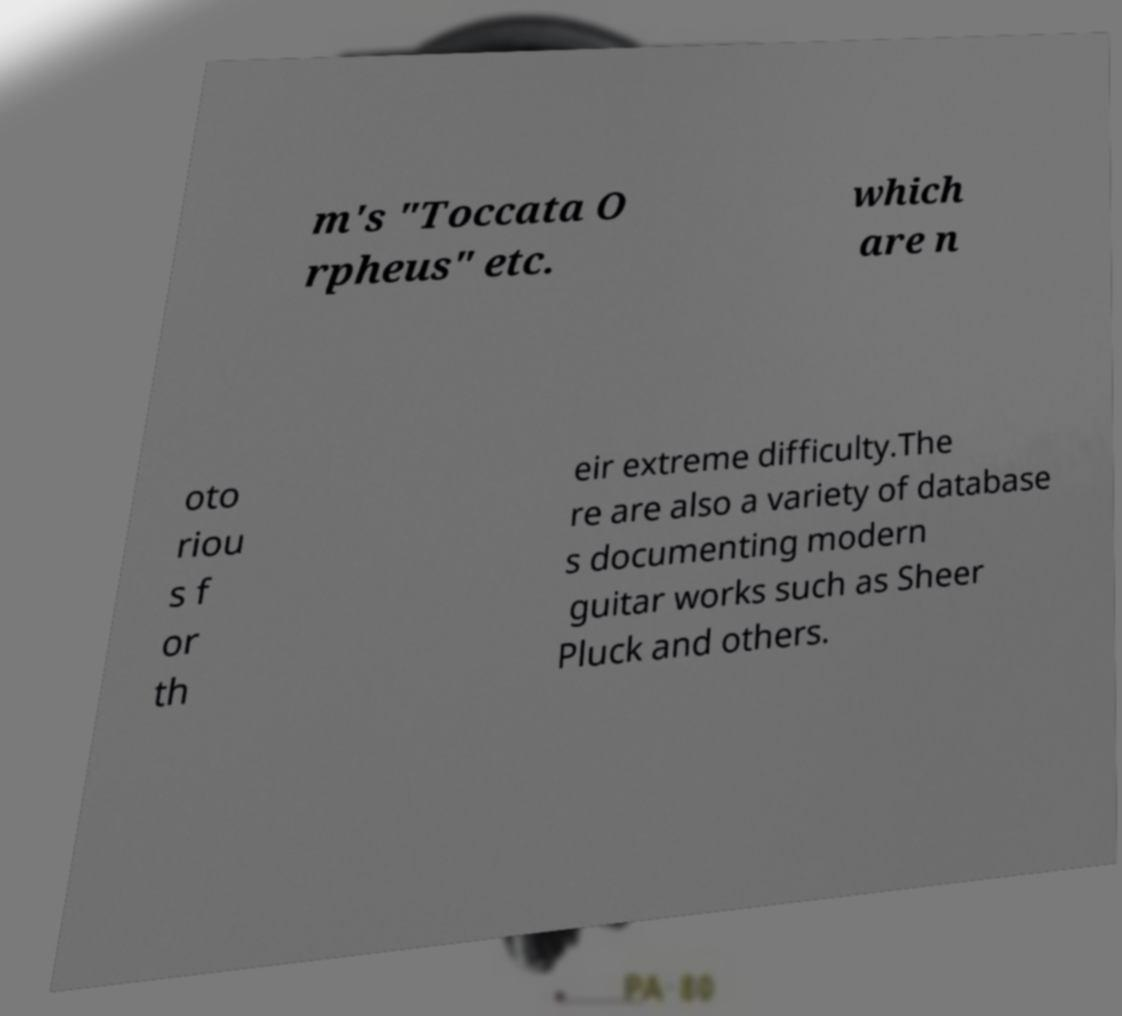Please identify and transcribe the text found in this image. m's "Toccata O rpheus" etc. which are n oto riou s f or th eir extreme difficulty.The re are also a variety of database s documenting modern guitar works such as Sheer Pluck and others. 